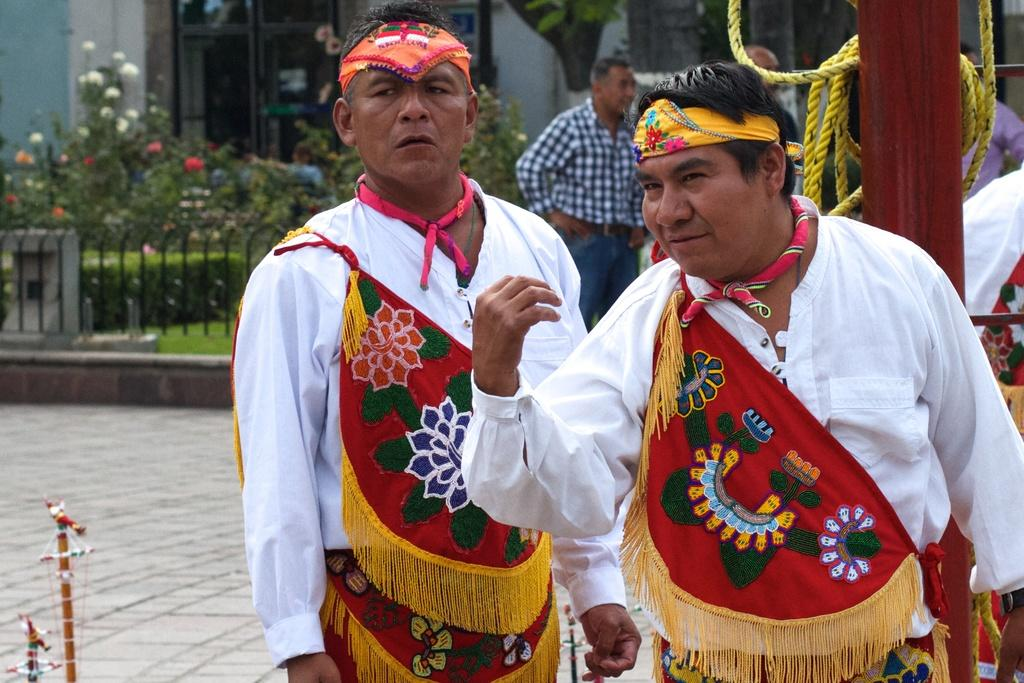What are the two persons in the image wearing? The two persons in the image are wearing costumes. What can be seen in the background of the image? In the background, there is a pole, a rope, people, railing, grass, flowering plants, and a building. Can you describe the setting of the image? The image appears to be set outdoors, with a grassy area and flowering plants visible in the background. What is the price of the stage in the image? There is no stage present in the image, so it is not possible to determine the price. 